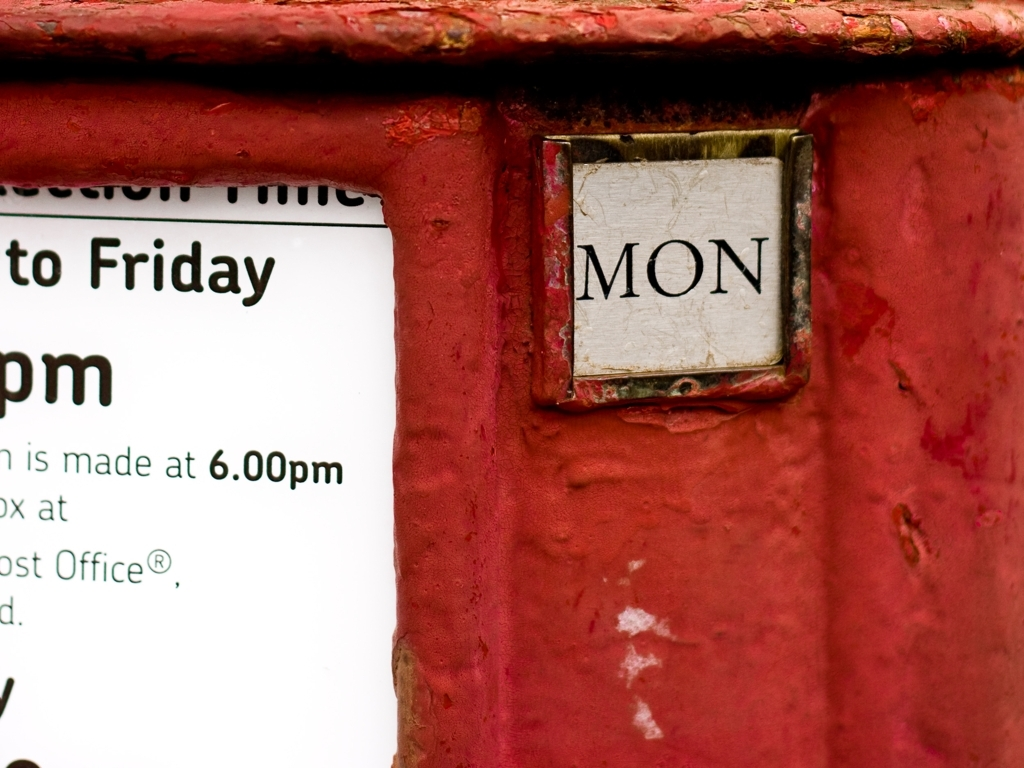What does the text on the sign indicate? The text on the sign indicates postal collection times and mentions that collection is made at 6.00 pm, Monday to Friday at the specified post box. 